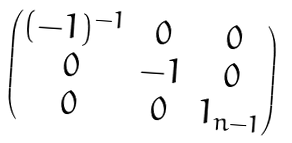<formula> <loc_0><loc_0><loc_500><loc_500>\begin{pmatrix} ( - 1 ) ^ { - 1 } & 0 & 0 \\ 0 & - 1 & 0 \\ 0 & 0 & 1 _ { n - 1 } \end{pmatrix}</formula> 